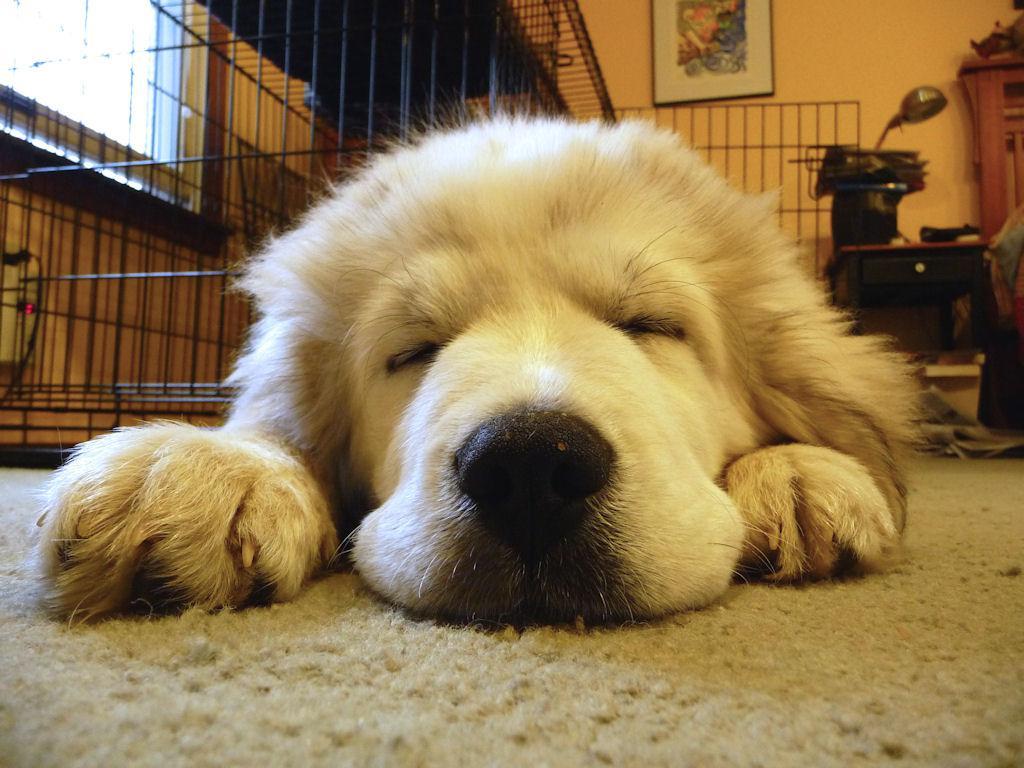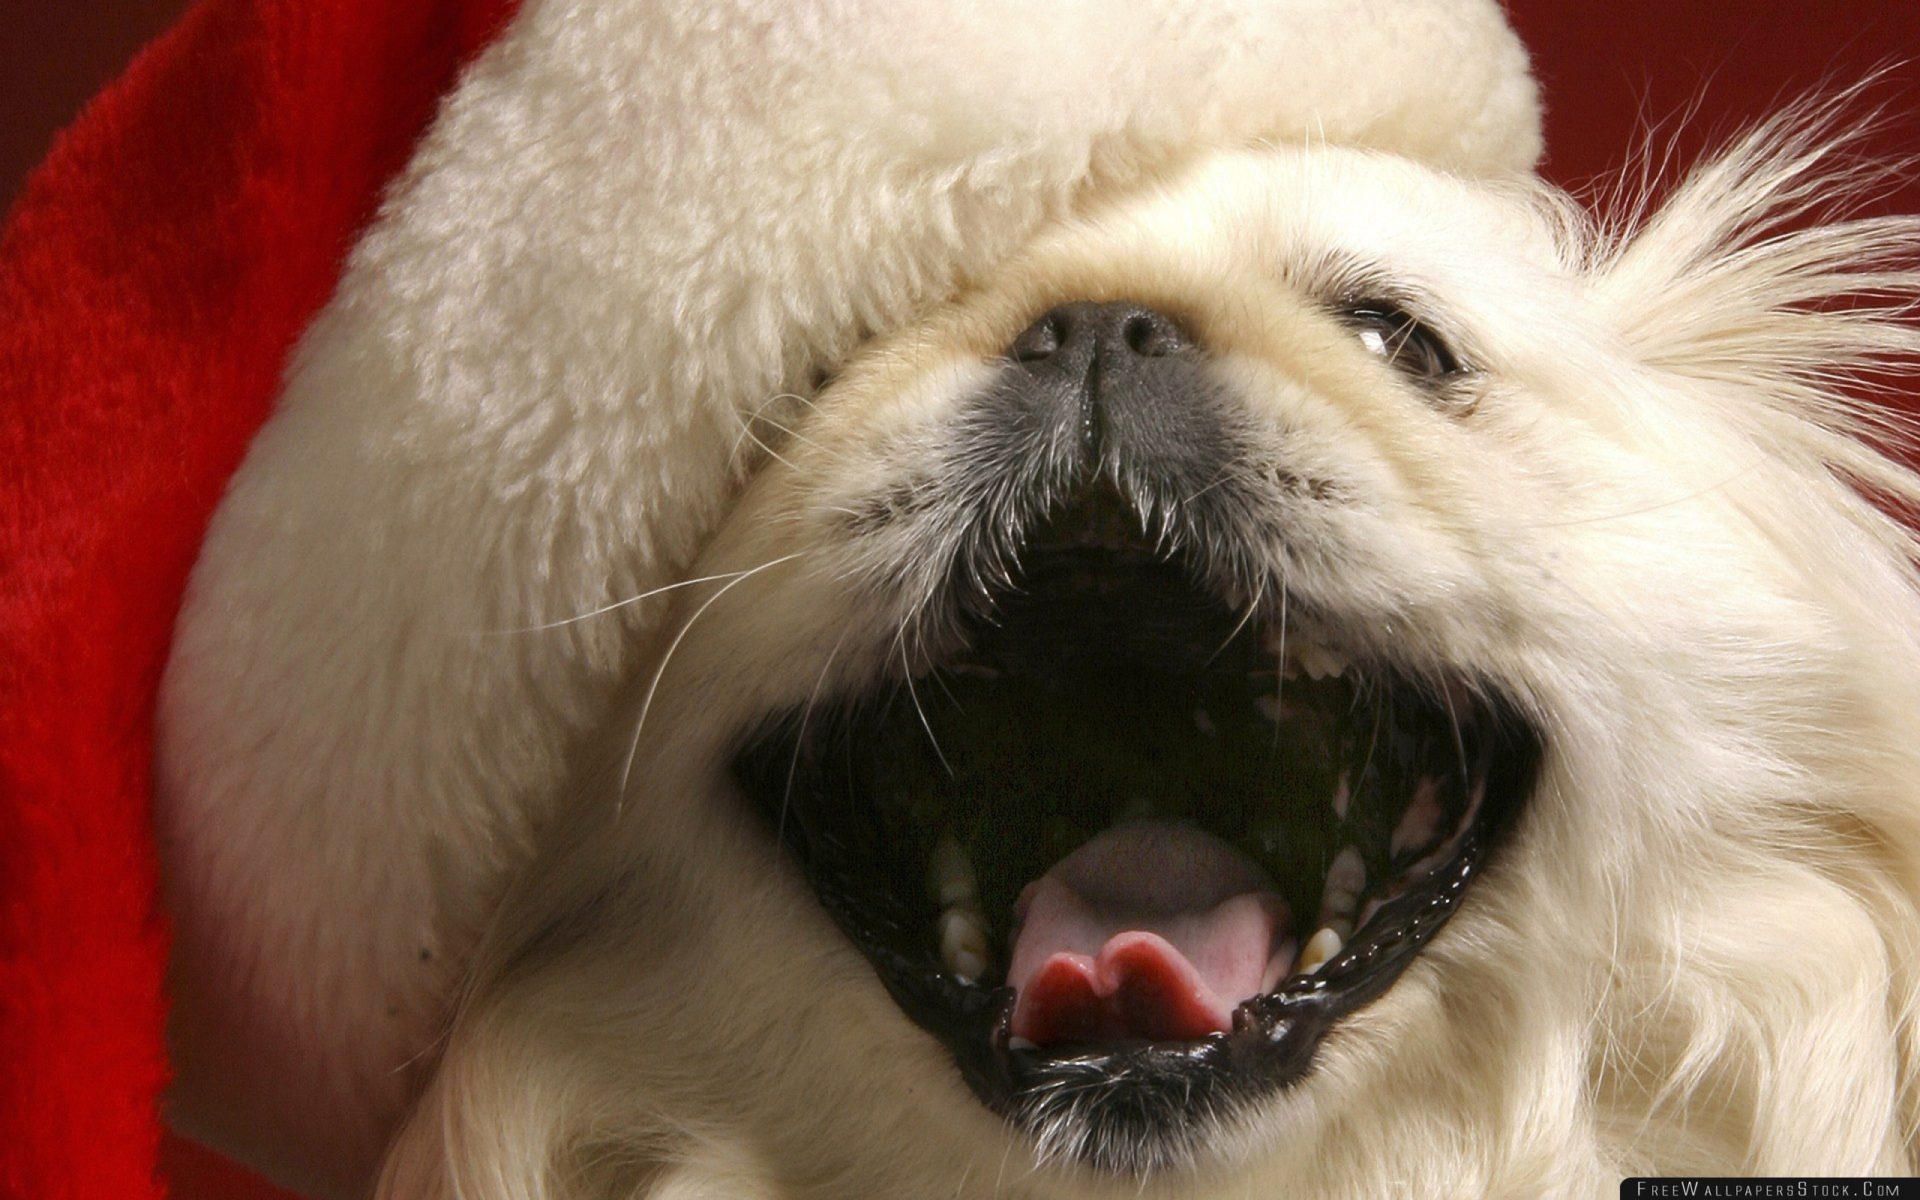The first image is the image on the left, the second image is the image on the right. Considering the images on both sides, is "The dog in only one of the images has its eyes open." valid? Answer yes or no. Yes. The first image is the image on the left, the second image is the image on the right. Analyze the images presented: Is the assertion "A bright red plush item is next to the head of the dog in one image." valid? Answer yes or no. Yes. 